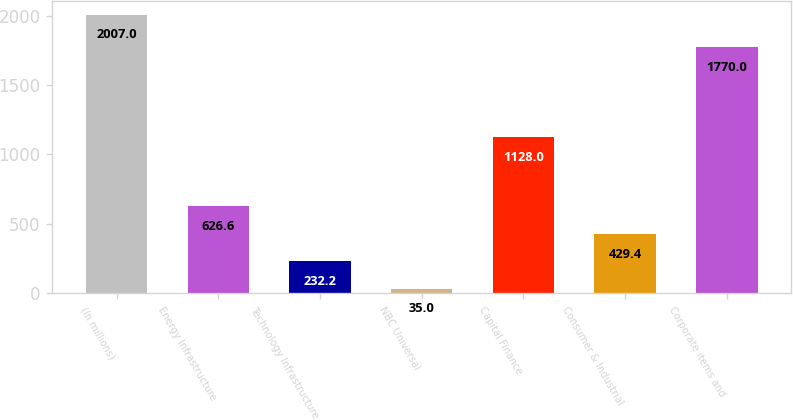Convert chart. <chart><loc_0><loc_0><loc_500><loc_500><bar_chart><fcel>(In millions)<fcel>Energy Infrastructure<fcel>Technology Infrastructure<fcel>NBC Universal<fcel>Capital Finance<fcel>Consumer & Industrial<fcel>Corporate items and<nl><fcel>2007<fcel>626.6<fcel>232.2<fcel>35<fcel>1128<fcel>429.4<fcel>1770<nl></chart> 